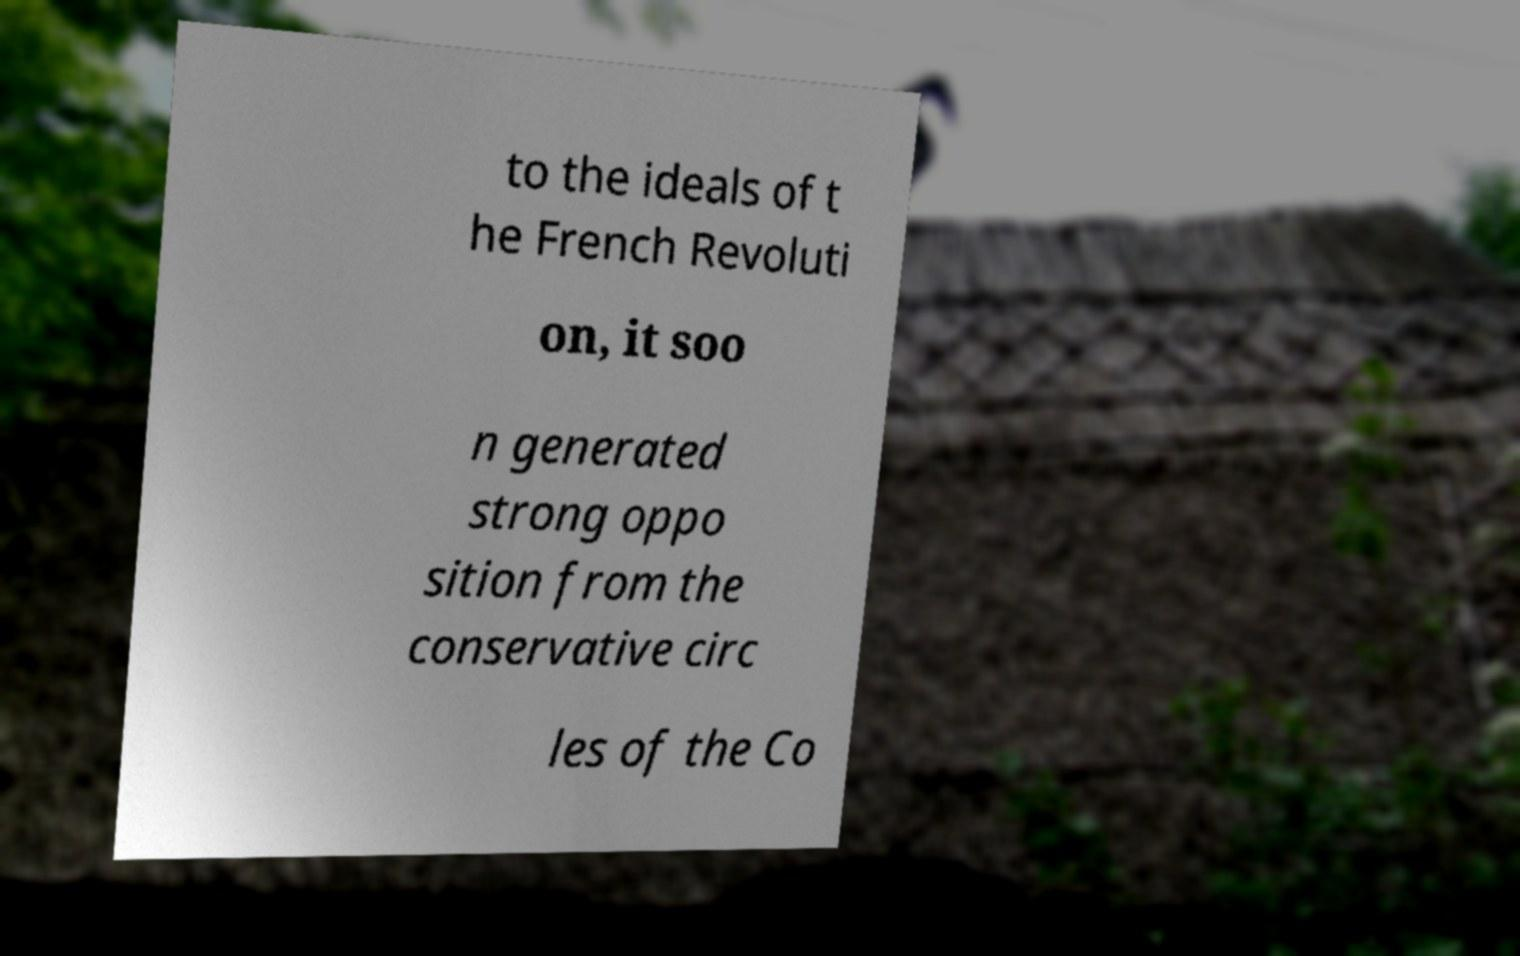There's text embedded in this image that I need extracted. Can you transcribe it verbatim? to the ideals of t he French Revoluti on, it soo n generated strong oppo sition from the conservative circ les of the Co 